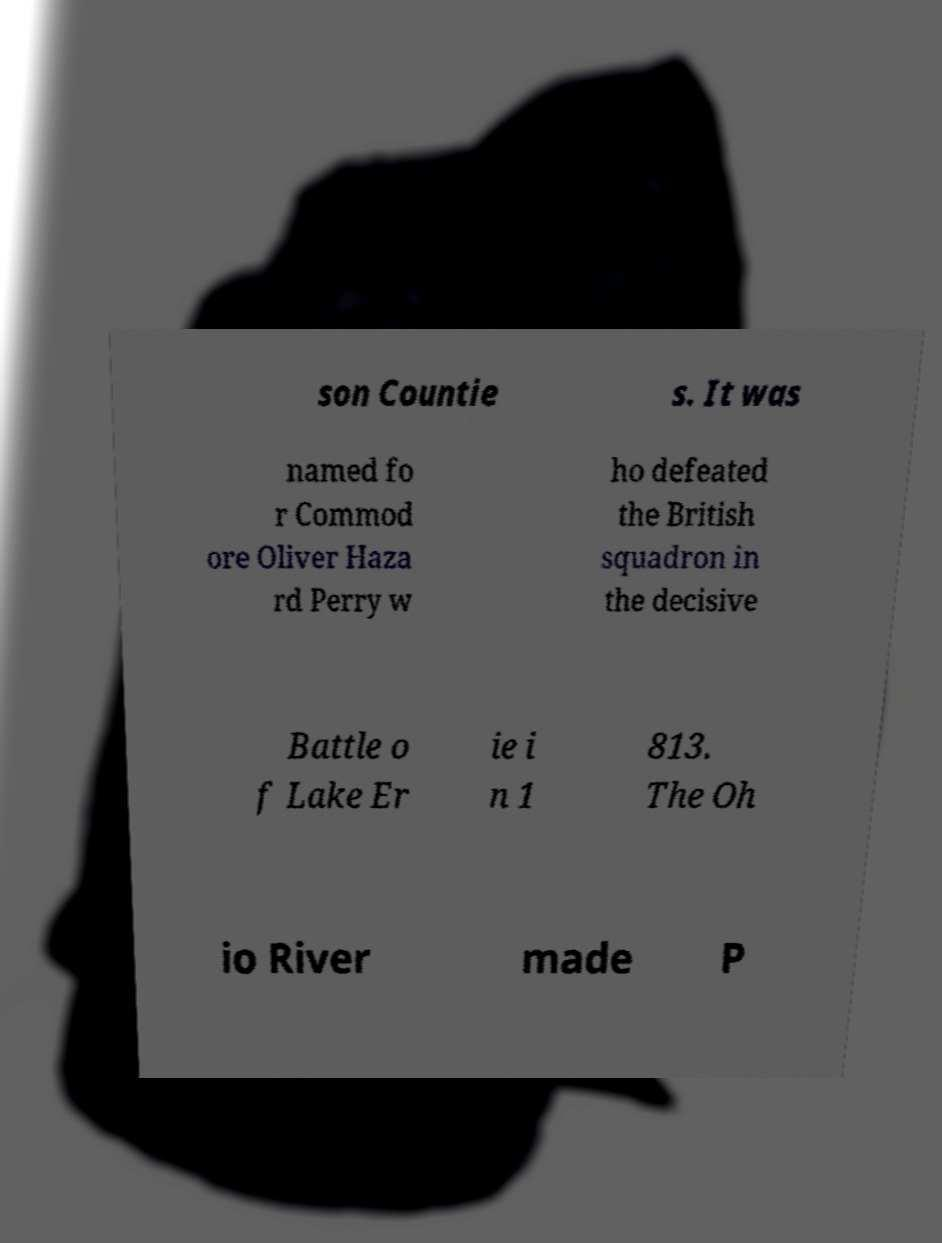Can you read and provide the text displayed in the image?This photo seems to have some interesting text. Can you extract and type it out for me? son Countie s. It was named fo r Commod ore Oliver Haza rd Perry w ho defeated the British squadron in the decisive Battle o f Lake Er ie i n 1 813. The Oh io River made P 